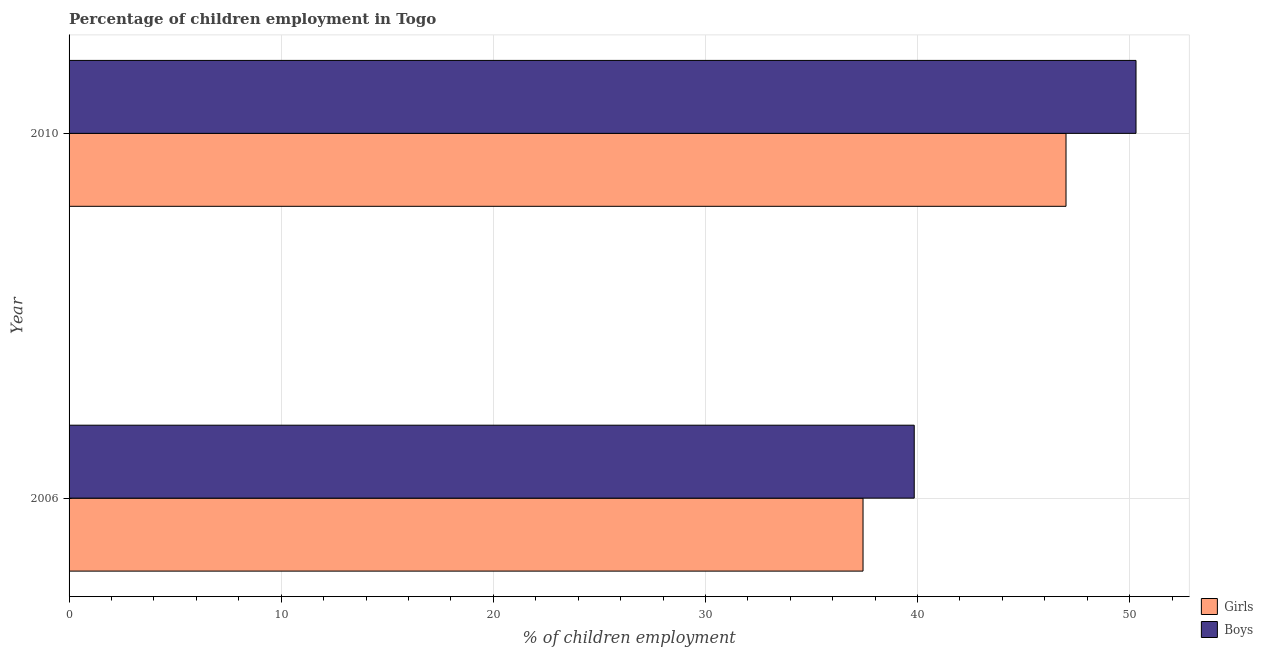How many groups of bars are there?
Offer a very short reply. 2. Are the number of bars per tick equal to the number of legend labels?
Your response must be concise. Yes. Are the number of bars on each tick of the Y-axis equal?
Your answer should be compact. Yes. How many bars are there on the 2nd tick from the bottom?
Give a very brief answer. 2. What is the label of the 2nd group of bars from the top?
Offer a terse response. 2006. In how many cases, is the number of bars for a given year not equal to the number of legend labels?
Keep it short and to the point. 0. Across all years, what is the maximum percentage of employed girls?
Keep it short and to the point. 47. Across all years, what is the minimum percentage of employed girls?
Your answer should be very brief. 37.43. In which year was the percentage of employed girls minimum?
Your answer should be very brief. 2006. What is the total percentage of employed boys in the graph?
Your response must be concise. 90.14. What is the difference between the percentage of employed boys in 2006 and that in 2010?
Your response must be concise. -10.46. What is the difference between the percentage of employed boys in 2010 and the percentage of employed girls in 2006?
Offer a terse response. 12.87. What is the average percentage of employed girls per year?
Provide a succinct answer. 42.22. In the year 2006, what is the difference between the percentage of employed girls and percentage of employed boys?
Offer a very short reply. -2.41. What is the ratio of the percentage of employed boys in 2006 to that in 2010?
Give a very brief answer. 0.79. Is the difference between the percentage of employed boys in 2006 and 2010 greater than the difference between the percentage of employed girls in 2006 and 2010?
Provide a succinct answer. No. What does the 1st bar from the top in 2010 represents?
Your answer should be compact. Boys. What does the 1st bar from the bottom in 2010 represents?
Your response must be concise. Girls. Are all the bars in the graph horizontal?
Offer a terse response. Yes. What is the difference between two consecutive major ticks on the X-axis?
Your answer should be very brief. 10. Are the values on the major ticks of X-axis written in scientific E-notation?
Your answer should be compact. No. Does the graph contain grids?
Offer a very short reply. Yes. Where does the legend appear in the graph?
Offer a terse response. Bottom right. How many legend labels are there?
Give a very brief answer. 2. How are the legend labels stacked?
Offer a terse response. Vertical. What is the title of the graph?
Offer a very short reply. Percentage of children employment in Togo. Does "Birth rate" appear as one of the legend labels in the graph?
Your answer should be compact. No. What is the label or title of the X-axis?
Provide a short and direct response. % of children employment. What is the % of children employment in Girls in 2006?
Your answer should be compact. 37.43. What is the % of children employment of Boys in 2006?
Offer a terse response. 39.84. What is the % of children employment in Girls in 2010?
Give a very brief answer. 47. What is the % of children employment of Boys in 2010?
Give a very brief answer. 50.3. Across all years, what is the maximum % of children employment in Boys?
Offer a very short reply. 50.3. Across all years, what is the minimum % of children employment in Girls?
Provide a succinct answer. 37.43. Across all years, what is the minimum % of children employment of Boys?
Offer a terse response. 39.84. What is the total % of children employment in Girls in the graph?
Give a very brief answer. 84.43. What is the total % of children employment of Boys in the graph?
Your answer should be compact. 90.14. What is the difference between the % of children employment of Girls in 2006 and that in 2010?
Provide a succinct answer. -9.57. What is the difference between the % of children employment in Boys in 2006 and that in 2010?
Your response must be concise. -10.46. What is the difference between the % of children employment of Girls in 2006 and the % of children employment of Boys in 2010?
Make the answer very short. -12.87. What is the average % of children employment of Girls per year?
Give a very brief answer. 42.22. What is the average % of children employment in Boys per year?
Offer a very short reply. 45.07. In the year 2006, what is the difference between the % of children employment of Girls and % of children employment of Boys?
Your answer should be very brief. -2.41. What is the ratio of the % of children employment in Girls in 2006 to that in 2010?
Your answer should be compact. 0.8. What is the ratio of the % of children employment of Boys in 2006 to that in 2010?
Make the answer very short. 0.79. What is the difference between the highest and the second highest % of children employment of Girls?
Ensure brevity in your answer.  9.57. What is the difference between the highest and the second highest % of children employment of Boys?
Offer a very short reply. 10.46. What is the difference between the highest and the lowest % of children employment in Girls?
Offer a terse response. 9.57. What is the difference between the highest and the lowest % of children employment in Boys?
Ensure brevity in your answer.  10.46. 